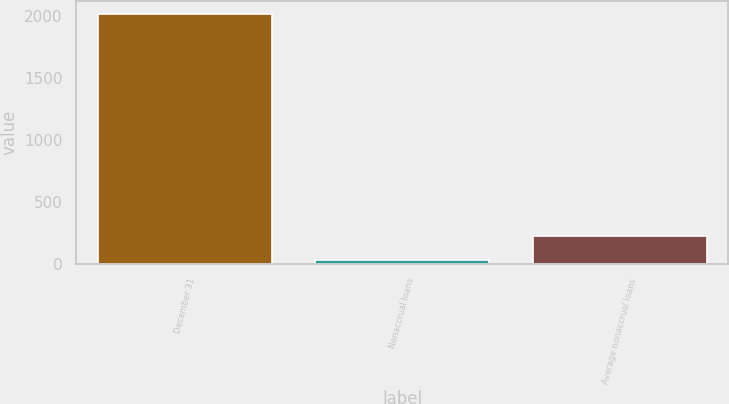Convert chart to OTSL. <chart><loc_0><loc_0><loc_500><loc_500><bar_chart><fcel>December 31<fcel>Nonaccrual loans<fcel>Average nonaccrual loans<nl><fcel>2015<fcel>28<fcel>226.7<nl></chart> 